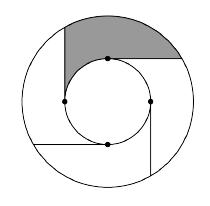Let $T$ be $7$. The diagram below features two concentric circles of radius $1$ and $T$ (not necessarily to scale). Four equally spaced points are chosen on the smaller circle, and rays are drawn from these points to the larger circle such that all of the rays are tangent to the smaller circle and no two rays intersect. If the area of the shaded region can be expressed as $k\pi$ for some integer $k$, find $k$.\n Answer is 12. 